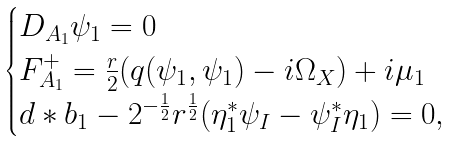Convert formula to latex. <formula><loc_0><loc_0><loc_500><loc_500>\begin{cases} D _ { A _ { 1 } } \psi _ { 1 } = 0 \\ F _ { A _ { 1 } } ^ { + } = \frac { r } { 2 } ( q ( \psi _ { 1 } , \psi _ { 1 } ) - i \Omega _ { X } ) + i \mu _ { 1 } \\ d * b _ { 1 } - 2 ^ { - \frac { 1 } { 2 } } r ^ { \frac { 1 } { 2 } } ( \eta _ { 1 } ^ { * } \psi _ { I } - \psi _ { I } ^ { * } \eta _ { 1 } ) = 0 , \end{cases}</formula> 